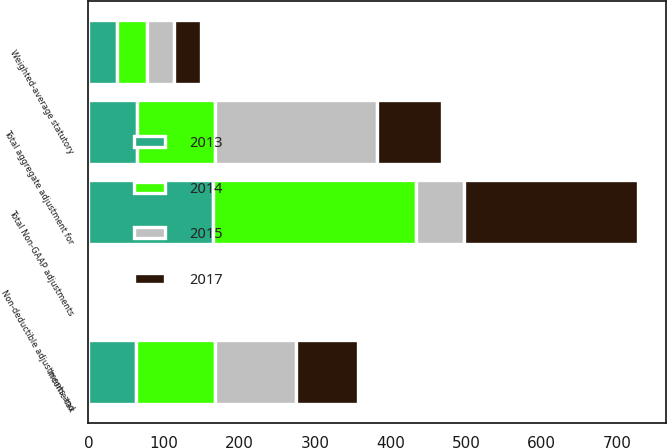Convert chart to OTSL. <chart><loc_0><loc_0><loc_500><loc_500><stacked_bar_chart><ecel><fcel>Total Non-GAAP adjustments<fcel>Weighted-average statutory<fcel>Income tax<fcel>Non-deductible adjustments and<fcel>Total aggregate adjustment for<nl><fcel>2015<fcel>64.8<fcel>36<fcel>107.2<fcel>2.7<fcel>214.9<nl><fcel>2017<fcel>230.4<fcel>36<fcel>82.9<fcel>0.4<fcel>85.8<nl><fcel>2013<fcel>165.2<fcel>38<fcel>62.8<fcel>1.3<fcel>64.8<nl><fcel>2014<fcel>268<fcel>39<fcel>104.5<fcel>1.5<fcel>103<nl></chart> 